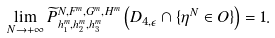Convert formula to latex. <formula><loc_0><loc_0><loc_500><loc_500>\lim _ { N \rightarrow + \infty } \widetilde { P } _ { h _ { 1 } ^ { m } , h _ { 2 } ^ { m } , h _ { 3 } ^ { m } } ^ { N , F ^ { m } , G ^ { m } , H ^ { m } } \left ( D _ { 4 , \epsilon } \cap \{ \eta ^ { N } \in O \} \right ) = 1 .</formula> 